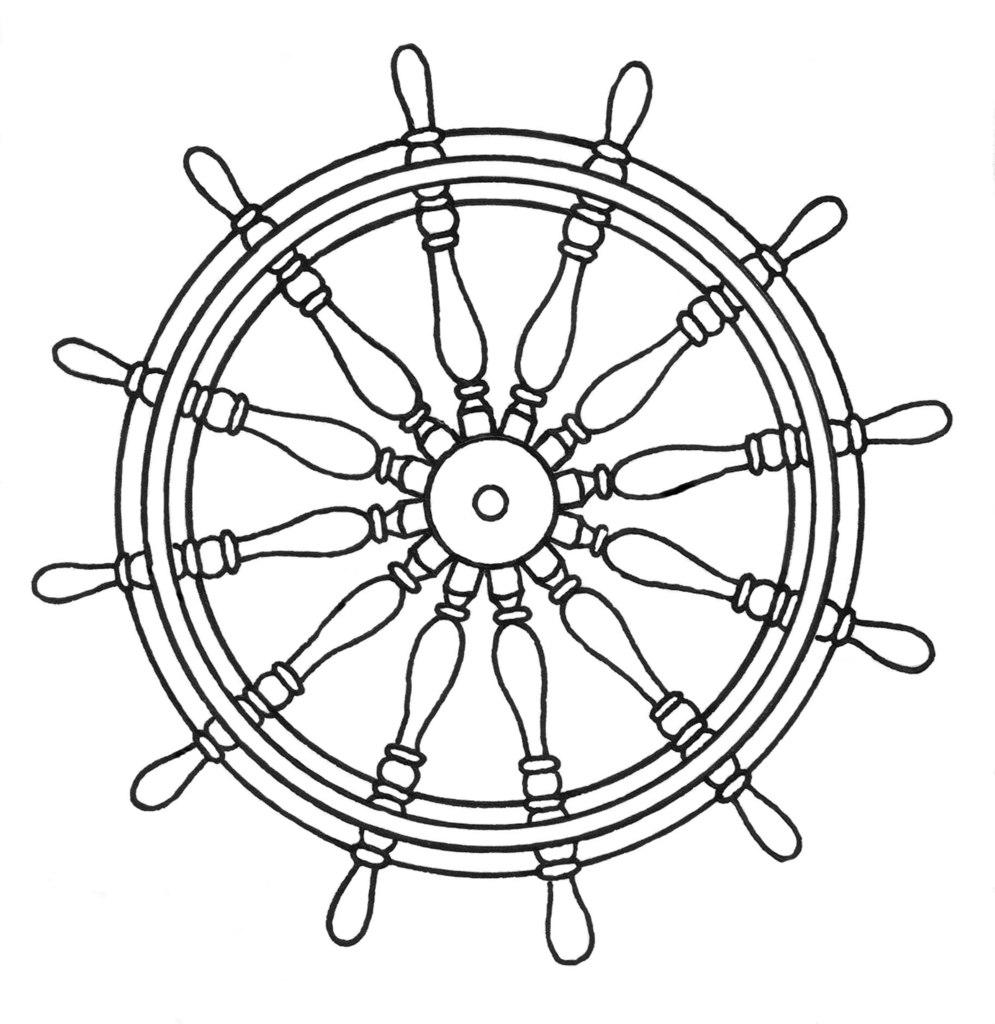What is the main subject of the sketch in the image? The main subject of the sketch in the image is a boat steering wheel. What color is the sketch? The sketch is black in color. What color is the background of the image? The background of the image is white. How many babies are present on the island in the image? There is no island or babies present in the image; it contains a sketch of a boat steering wheel with a black color on a white background. 